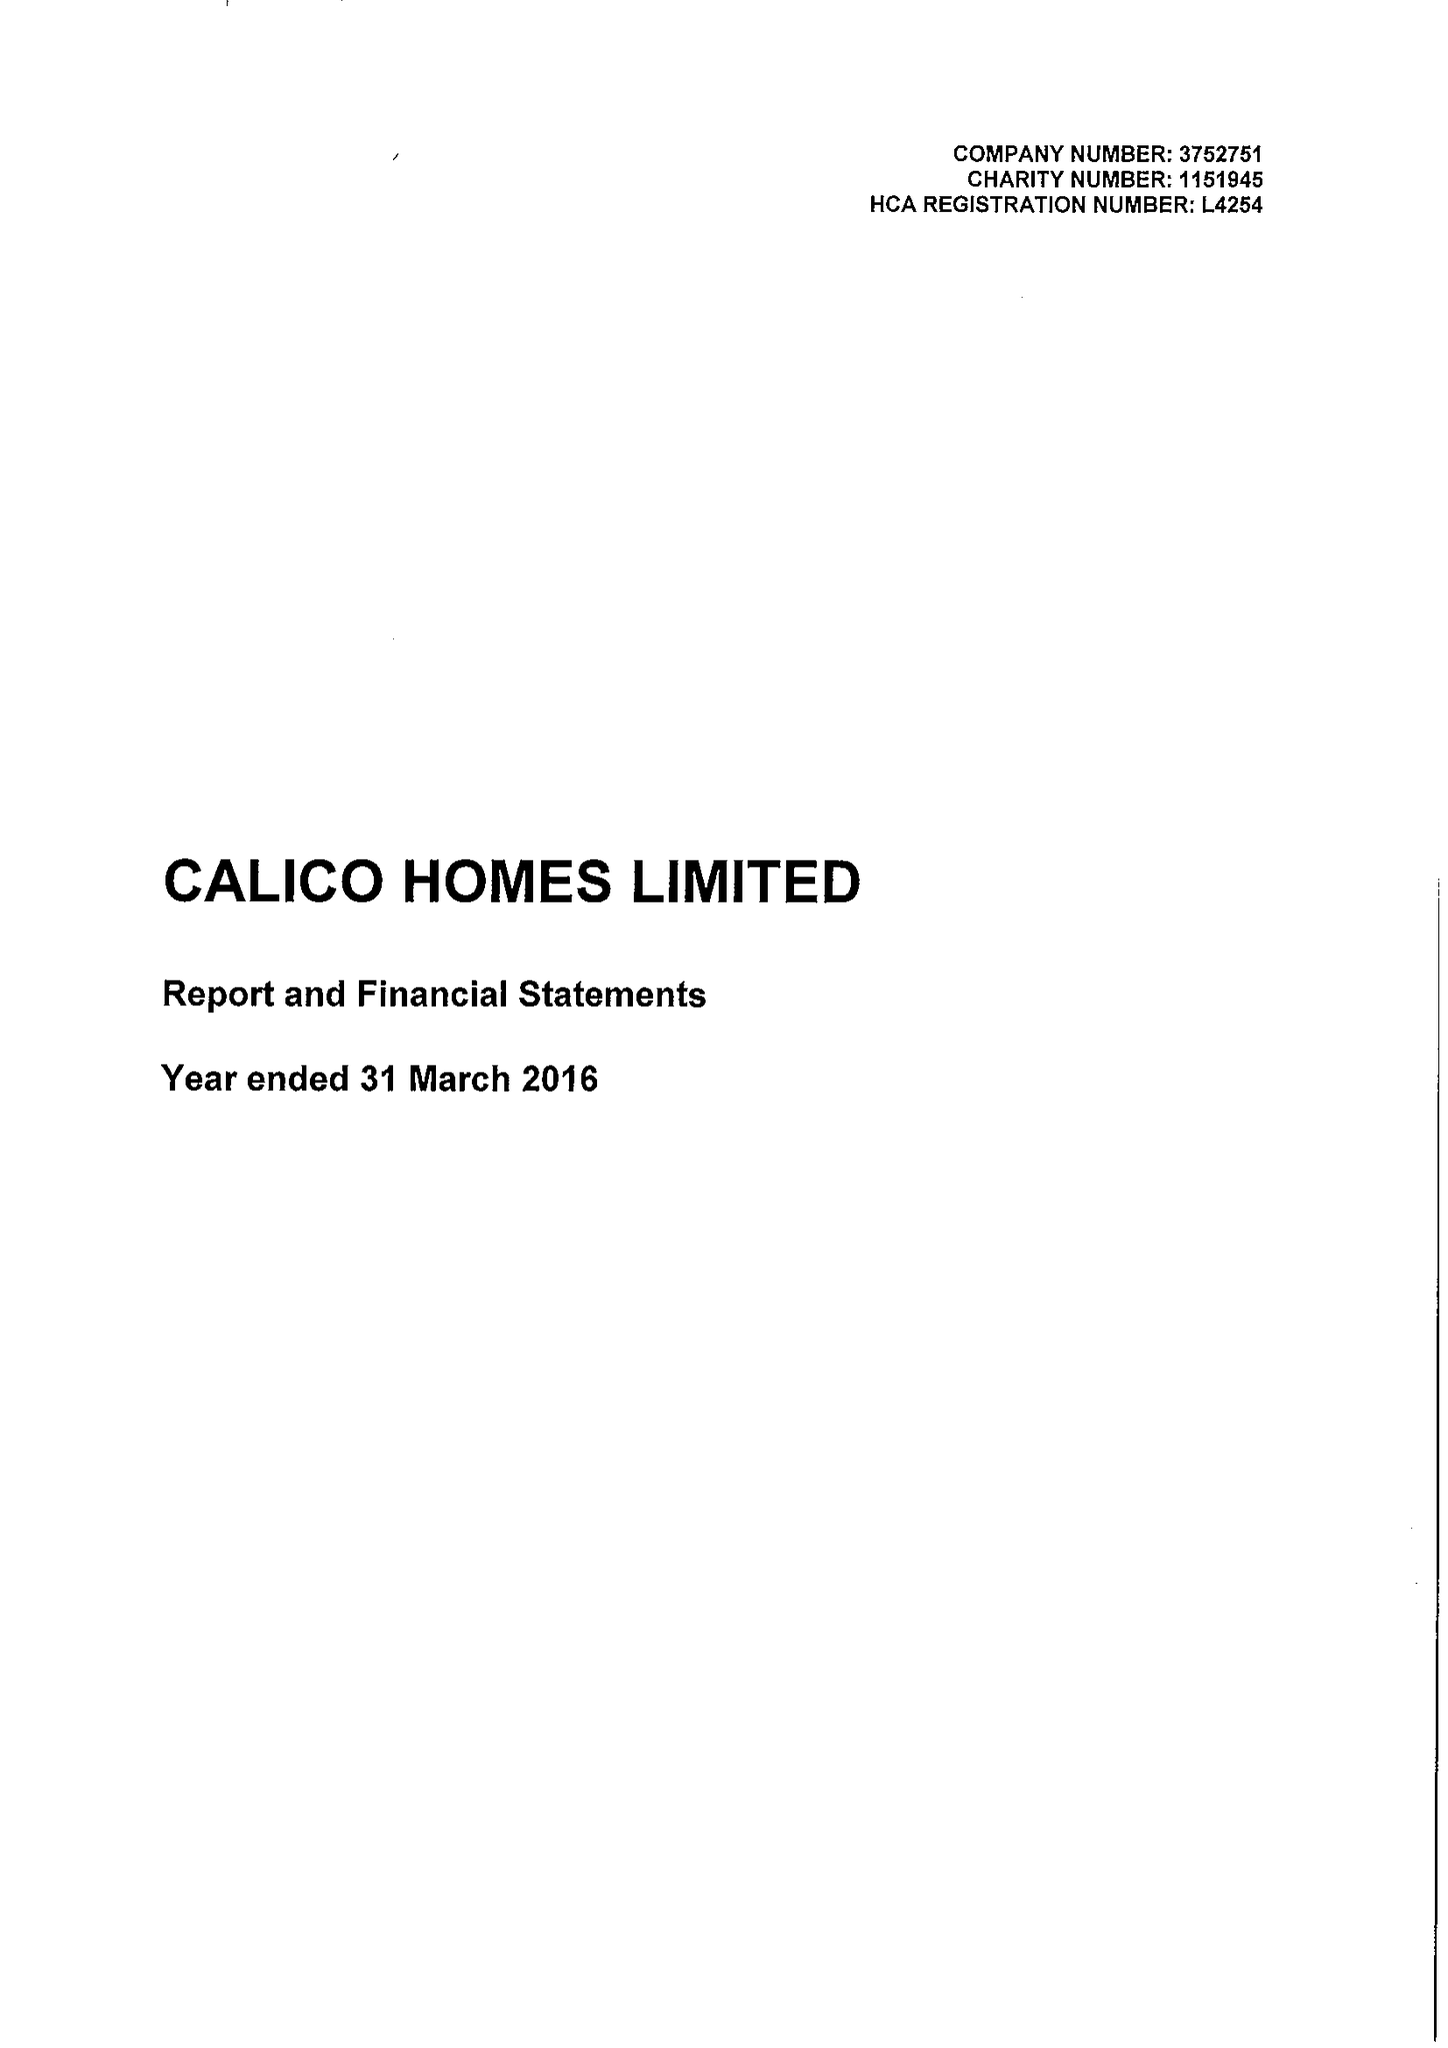What is the value for the charity_name?
Answer the question using a single word or phrase. Calico Homes Ltd. 